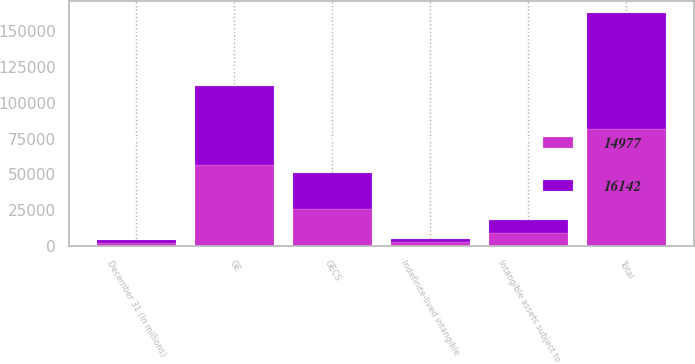Convert chart. <chart><loc_0><loc_0><loc_500><loc_500><stacked_bar_chart><ecel><fcel>December 31 (In millions)<fcel>GE<fcel>GECS<fcel>Total<fcel>Intangible assets subject to<fcel>Indefinite-lived intangible<nl><fcel>14977<fcel>2008<fcel>56394<fcel>25365<fcel>81759<fcel>9010<fcel>2354<nl><fcel>16142<fcel>2007<fcel>55689<fcel>25427<fcel>81116<fcel>9278<fcel>2355<nl></chart> 